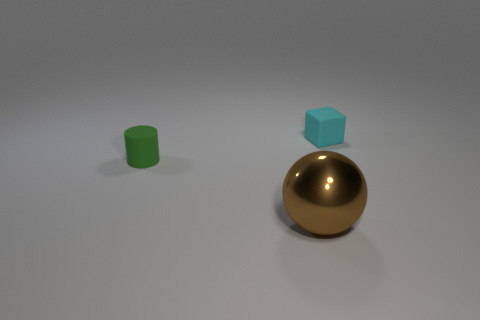Are there more shiny spheres than tiny gray metal blocks?
Provide a short and direct response. Yes. Are there any brown spheres made of the same material as the small block?
Ensure brevity in your answer.  No. The thing that is on the right side of the green cylinder and behind the shiny ball has what shape?
Your answer should be very brief. Cube. What number of other things are there of the same shape as the green thing?
Give a very brief answer. 0. What is the size of the cyan matte block?
Your response must be concise. Small. How many things are big purple things or green things?
Ensure brevity in your answer.  1. What size is the thing that is in front of the tiny green object?
Keep it short and to the point. Large. Are there any other things that have the same size as the cylinder?
Your response must be concise. Yes. There is a thing that is behind the brown object and right of the cylinder; what color is it?
Offer a terse response. Cyan. Is the material of the tiny object right of the small green matte cylinder the same as the large brown sphere?
Provide a short and direct response. No. 